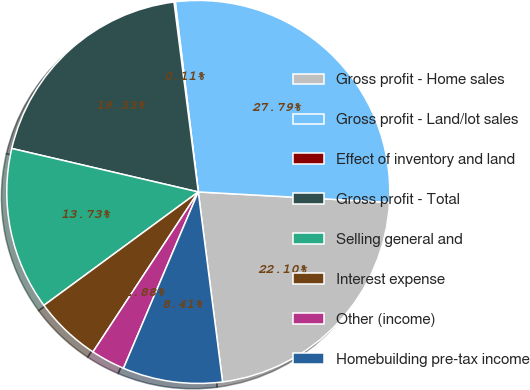<chart> <loc_0><loc_0><loc_500><loc_500><pie_chart><fcel>Gross profit - Home sales<fcel>Gross profit - Land/lot sales<fcel>Effect of inventory and land<fcel>Gross profit - Total<fcel>Selling general and<fcel>Interest expense<fcel>Other (income)<fcel>Homebuilding pre-tax income<nl><fcel>22.1%<fcel>27.79%<fcel>0.11%<fcel>19.33%<fcel>13.73%<fcel>5.65%<fcel>2.88%<fcel>8.41%<nl></chart> 